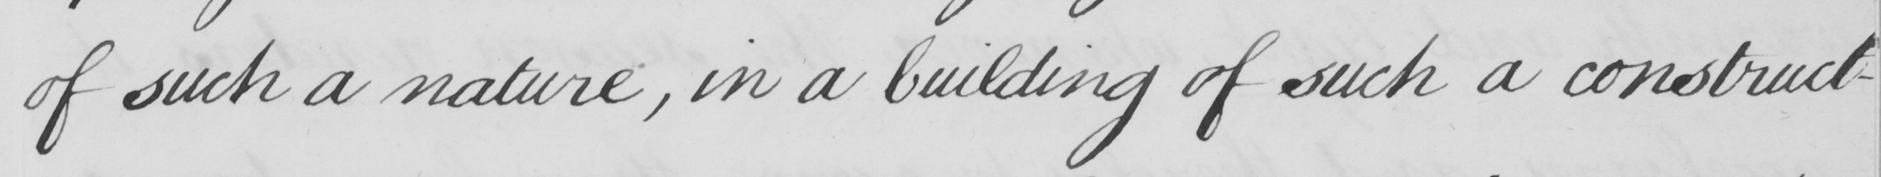Please provide the text content of this handwritten line. of such a nature , in a building of such a construct- 